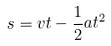<formula> <loc_0><loc_0><loc_500><loc_500>s = v t - \frac { 1 } { 2 } a t ^ { 2 }</formula> 